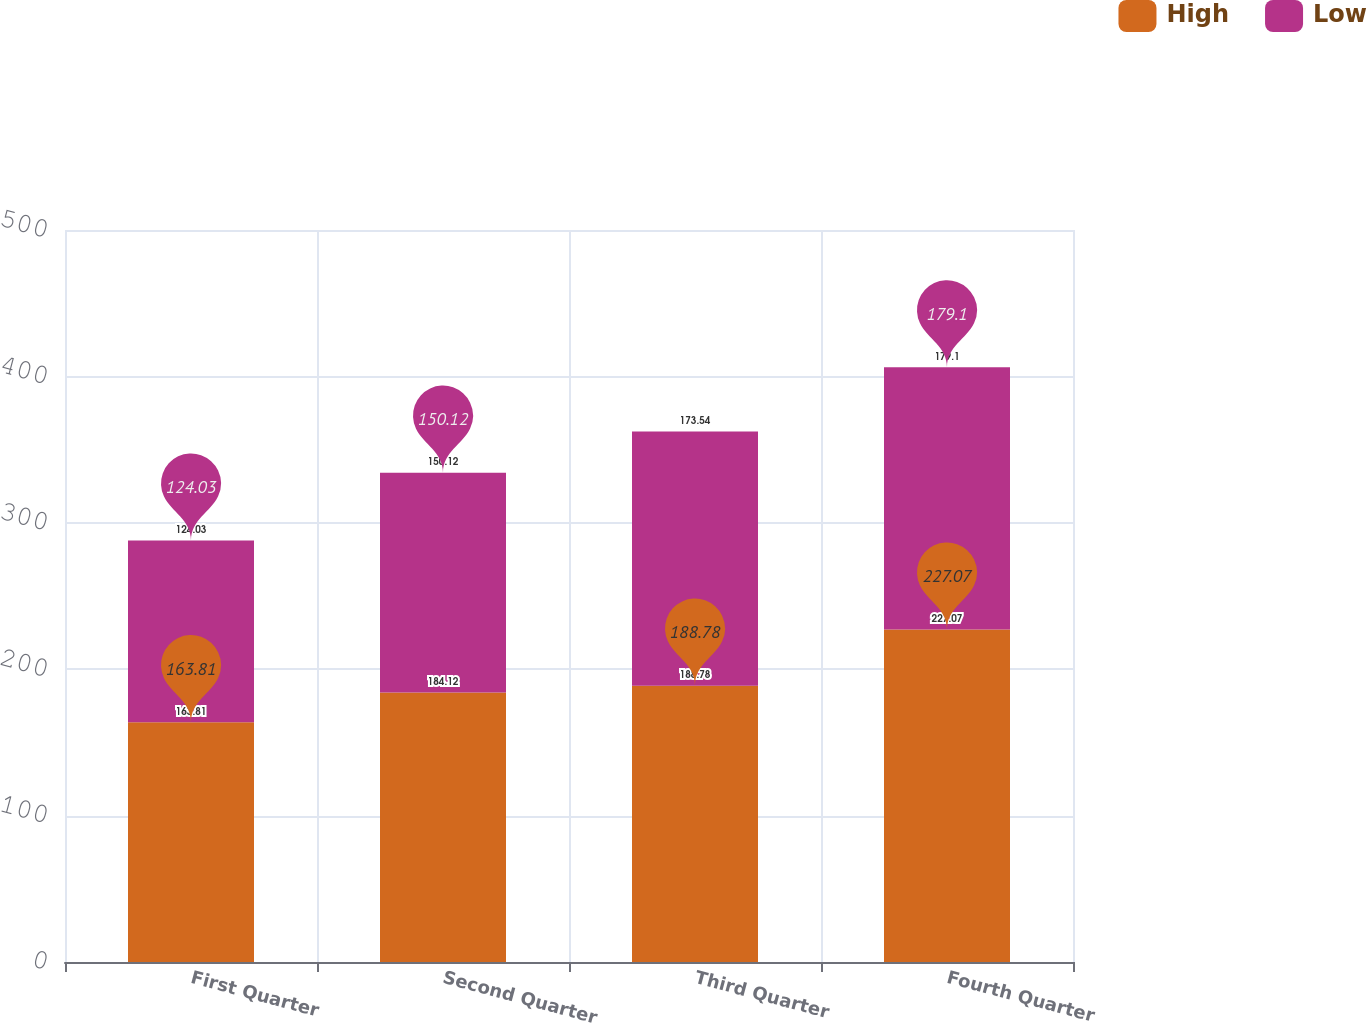Convert chart. <chart><loc_0><loc_0><loc_500><loc_500><stacked_bar_chart><ecel><fcel>First Quarter<fcel>Second Quarter<fcel>Third Quarter<fcel>Fourth Quarter<nl><fcel>High<fcel>163.81<fcel>184.12<fcel>188.78<fcel>227.07<nl><fcel>Low<fcel>124.03<fcel>150.12<fcel>173.54<fcel>179.1<nl></chart> 